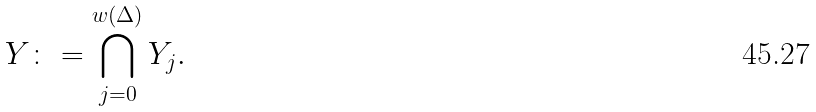Convert formula to latex. <formula><loc_0><loc_0><loc_500><loc_500>Y \colon = \bigcap _ { j = 0 } ^ { w ( \Delta ) } Y _ { j } .</formula> 